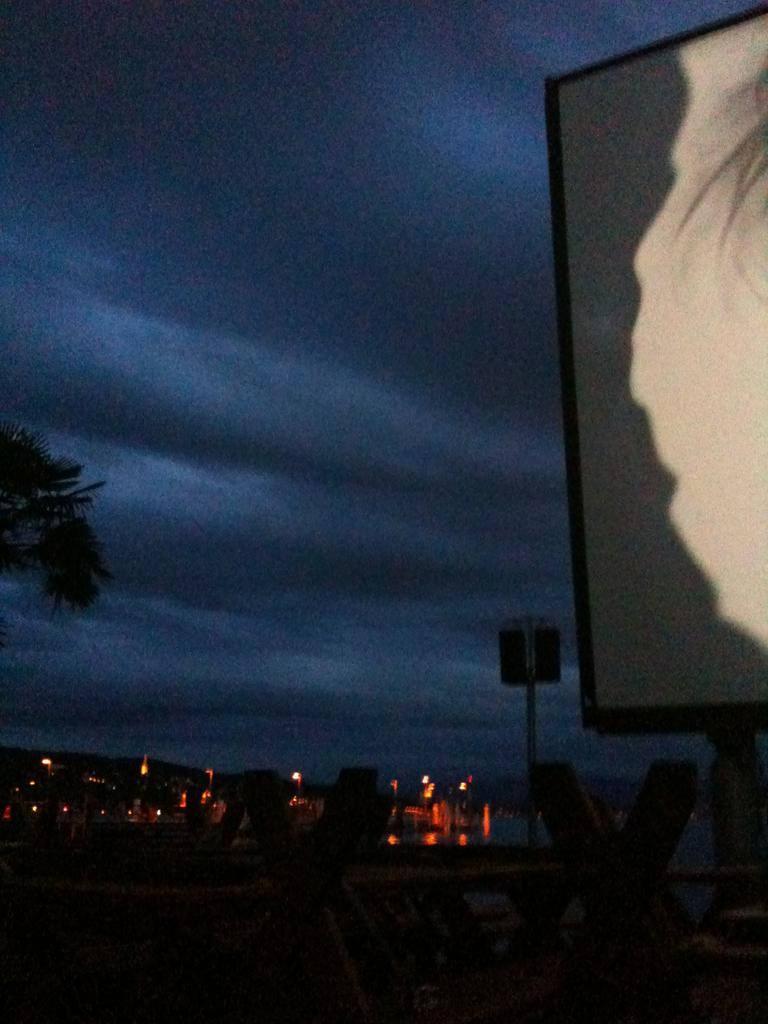How would you summarize this image in a sentence or two? In this picture we can see the night view. Behind there are some lights in the restaurant. In the front there are some relaxing benches and on the right corner we can see a white board and tree. 